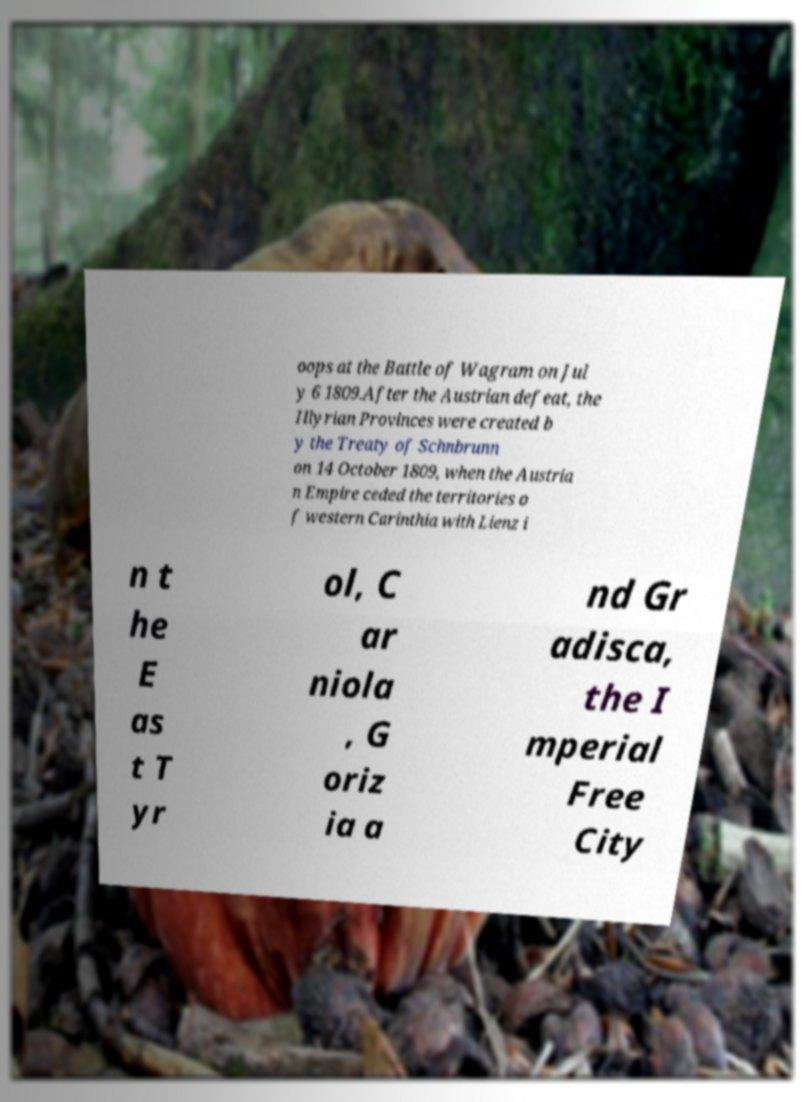For documentation purposes, I need the text within this image transcribed. Could you provide that? oops at the Battle of Wagram on Jul y 6 1809.After the Austrian defeat, the Illyrian Provinces were created b y the Treaty of Schnbrunn on 14 October 1809, when the Austria n Empire ceded the territories o f western Carinthia with Lienz i n t he E as t T yr ol, C ar niola , G oriz ia a nd Gr adisca, the I mperial Free City 